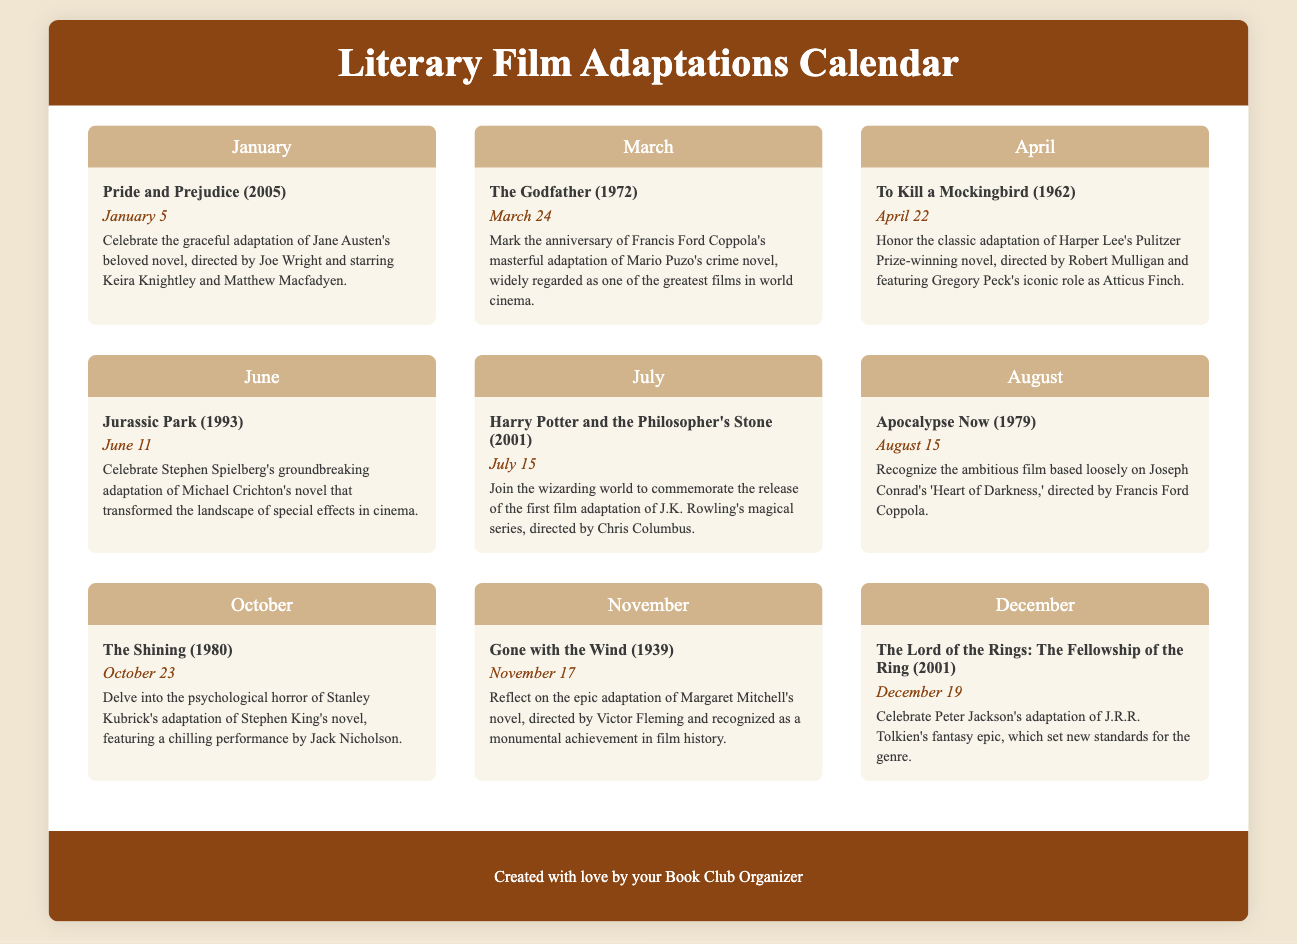What literary classic was adapted into a film released on January 5? The event on January 5 is about the adaptation of Jane Austen's "Pride and Prejudice."
Answer: Pride and Prejudice Which film adaptation celebrates its anniversary on March 24? The event on March 24 is for "The Godfather," adapted from Mario Puzo's crime novel.
Answer: The Godfather Who directed the adaptation of "To Kill a Mockingbird"? The event description specifies that "To Kill a Mockingbird" was directed by Robert Mulligan.
Answer: Robert Mulligan When was "Harry Potter and the Philosopher's Stone" released? The event for "Harry Potter and the Philosopher's Stone" states that its release date is July 15, 2001.
Answer: July 15, 2001 What is the theme of the film "The Shining"? The event description highlights the psychological horror of "The Shining," which is an adaptation of Stephen King's novel.
Answer: Psychological horror Which director is associated with the adaptation of "Gone with the Wind"? The event mentions that "Gone with the Wind" was directed by Victor Fleming.
Answer: Victor Fleming What significant cinematic achievement is recognized with "The Lord of the Rings: The Fellowship of the Ring"? The description highlights that it set new standards for the fantasy genre.
Answer: New standards for the genre Which film adaptation is loosely based on "Heart of Darkness"? According to the August event, "Apocalypse Now" is based loosely on Joseph Conrad's "Heart of Darkness."
Answer: Apocalypse Now What iconic role is Gregory Peck known for in "To Kill a Mockingbird"? The event description states that Gregory Peck's role in "To Kill a Mockingbird" is iconic as Atticus Finch.
Answer: Atticus Finch 